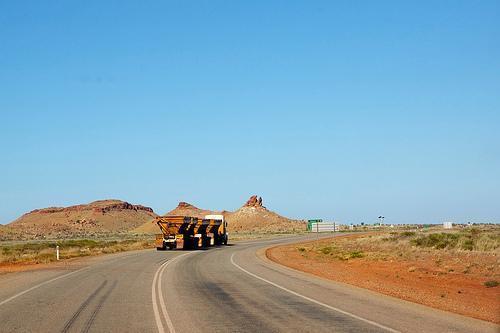How many trucks are shown?
Give a very brief answer. 1. 